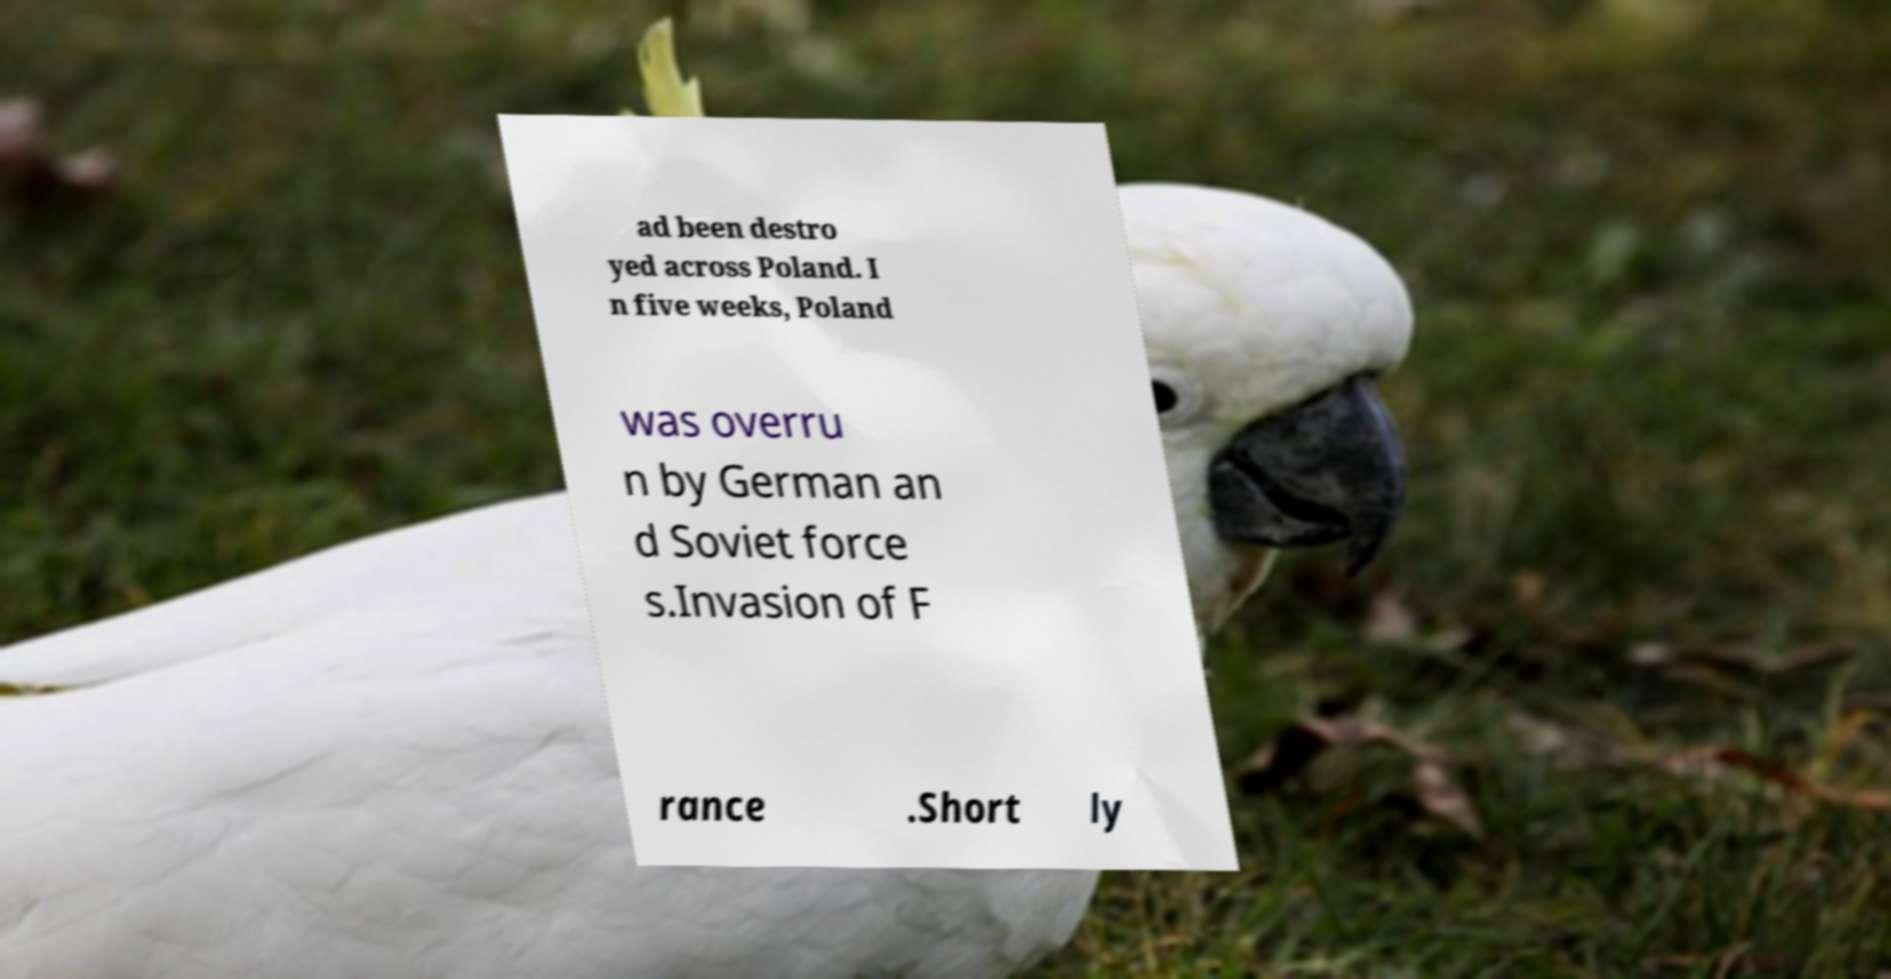What messages or text are displayed in this image? I need them in a readable, typed format. ad been destro yed across Poland. I n five weeks, Poland was overru n by German an d Soviet force s.Invasion of F rance .Short ly 